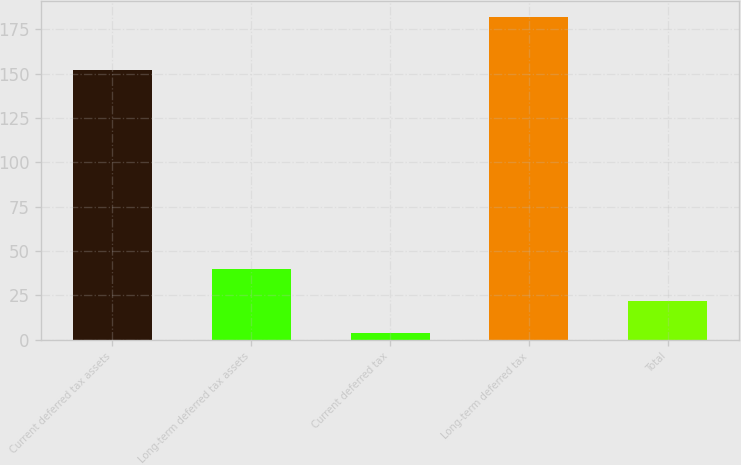Convert chart to OTSL. <chart><loc_0><loc_0><loc_500><loc_500><bar_chart><fcel>Current deferred tax assets<fcel>Long-term deferred tax assets<fcel>Current deferred tax<fcel>Long-term deferred tax<fcel>Total<nl><fcel>152<fcel>39.6<fcel>4<fcel>182<fcel>21.8<nl></chart> 